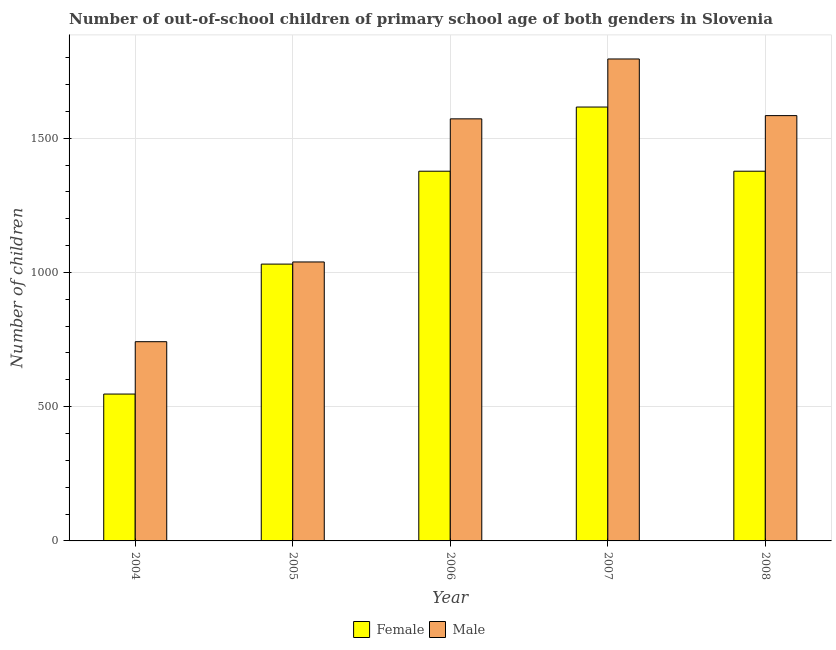How many different coloured bars are there?
Your answer should be compact. 2. How many groups of bars are there?
Keep it short and to the point. 5. Are the number of bars per tick equal to the number of legend labels?
Provide a succinct answer. Yes. Are the number of bars on each tick of the X-axis equal?
Give a very brief answer. Yes. How many bars are there on the 3rd tick from the left?
Your answer should be very brief. 2. How many bars are there on the 5th tick from the right?
Provide a short and direct response. 2. In how many cases, is the number of bars for a given year not equal to the number of legend labels?
Offer a terse response. 0. What is the number of male out-of-school students in 2004?
Give a very brief answer. 742. Across all years, what is the maximum number of male out-of-school students?
Keep it short and to the point. 1795. Across all years, what is the minimum number of female out-of-school students?
Make the answer very short. 547. In which year was the number of female out-of-school students maximum?
Make the answer very short. 2007. What is the total number of female out-of-school students in the graph?
Your response must be concise. 5948. What is the difference between the number of male out-of-school students in 2004 and that in 2007?
Give a very brief answer. -1053. What is the difference between the number of male out-of-school students in 2005 and the number of female out-of-school students in 2006?
Offer a terse response. -533. What is the average number of female out-of-school students per year?
Your answer should be compact. 1189.6. In the year 2007, what is the difference between the number of male out-of-school students and number of female out-of-school students?
Provide a succinct answer. 0. What is the ratio of the number of female out-of-school students in 2004 to that in 2007?
Make the answer very short. 0.34. Is the difference between the number of female out-of-school students in 2004 and 2007 greater than the difference between the number of male out-of-school students in 2004 and 2007?
Provide a succinct answer. No. What is the difference between the highest and the second highest number of male out-of-school students?
Your answer should be compact. 211. What is the difference between the highest and the lowest number of male out-of-school students?
Provide a succinct answer. 1053. In how many years, is the number of male out-of-school students greater than the average number of male out-of-school students taken over all years?
Give a very brief answer. 3. What does the 1st bar from the right in 2004 represents?
Provide a succinct answer. Male. How many bars are there?
Your answer should be compact. 10. How many years are there in the graph?
Offer a very short reply. 5. What is the difference between two consecutive major ticks on the Y-axis?
Keep it short and to the point. 500. Does the graph contain grids?
Your response must be concise. Yes. Where does the legend appear in the graph?
Your answer should be compact. Bottom center. How are the legend labels stacked?
Provide a succinct answer. Horizontal. What is the title of the graph?
Offer a very short reply. Number of out-of-school children of primary school age of both genders in Slovenia. Does "Malaria" appear as one of the legend labels in the graph?
Keep it short and to the point. No. What is the label or title of the X-axis?
Your response must be concise. Year. What is the label or title of the Y-axis?
Your answer should be compact. Number of children. What is the Number of children of Female in 2004?
Your answer should be very brief. 547. What is the Number of children of Male in 2004?
Keep it short and to the point. 742. What is the Number of children in Female in 2005?
Your answer should be very brief. 1031. What is the Number of children of Male in 2005?
Keep it short and to the point. 1039. What is the Number of children in Female in 2006?
Your response must be concise. 1377. What is the Number of children of Male in 2006?
Ensure brevity in your answer.  1572. What is the Number of children of Female in 2007?
Offer a very short reply. 1616. What is the Number of children of Male in 2007?
Offer a terse response. 1795. What is the Number of children in Female in 2008?
Your response must be concise. 1377. What is the Number of children of Male in 2008?
Offer a terse response. 1584. Across all years, what is the maximum Number of children in Female?
Offer a very short reply. 1616. Across all years, what is the maximum Number of children in Male?
Give a very brief answer. 1795. Across all years, what is the minimum Number of children of Female?
Make the answer very short. 547. Across all years, what is the minimum Number of children in Male?
Your answer should be very brief. 742. What is the total Number of children in Female in the graph?
Give a very brief answer. 5948. What is the total Number of children in Male in the graph?
Provide a succinct answer. 6732. What is the difference between the Number of children in Female in 2004 and that in 2005?
Offer a terse response. -484. What is the difference between the Number of children in Male in 2004 and that in 2005?
Provide a succinct answer. -297. What is the difference between the Number of children of Female in 2004 and that in 2006?
Keep it short and to the point. -830. What is the difference between the Number of children of Male in 2004 and that in 2006?
Give a very brief answer. -830. What is the difference between the Number of children in Female in 2004 and that in 2007?
Make the answer very short. -1069. What is the difference between the Number of children in Male in 2004 and that in 2007?
Give a very brief answer. -1053. What is the difference between the Number of children of Female in 2004 and that in 2008?
Make the answer very short. -830. What is the difference between the Number of children of Male in 2004 and that in 2008?
Ensure brevity in your answer.  -842. What is the difference between the Number of children of Female in 2005 and that in 2006?
Offer a terse response. -346. What is the difference between the Number of children of Male in 2005 and that in 2006?
Keep it short and to the point. -533. What is the difference between the Number of children of Female in 2005 and that in 2007?
Make the answer very short. -585. What is the difference between the Number of children in Male in 2005 and that in 2007?
Your answer should be very brief. -756. What is the difference between the Number of children of Female in 2005 and that in 2008?
Offer a very short reply. -346. What is the difference between the Number of children of Male in 2005 and that in 2008?
Offer a very short reply. -545. What is the difference between the Number of children in Female in 2006 and that in 2007?
Ensure brevity in your answer.  -239. What is the difference between the Number of children of Male in 2006 and that in 2007?
Make the answer very short. -223. What is the difference between the Number of children of Female in 2006 and that in 2008?
Make the answer very short. 0. What is the difference between the Number of children in Female in 2007 and that in 2008?
Your response must be concise. 239. What is the difference between the Number of children of Male in 2007 and that in 2008?
Ensure brevity in your answer.  211. What is the difference between the Number of children of Female in 2004 and the Number of children of Male in 2005?
Give a very brief answer. -492. What is the difference between the Number of children of Female in 2004 and the Number of children of Male in 2006?
Your response must be concise. -1025. What is the difference between the Number of children in Female in 2004 and the Number of children in Male in 2007?
Your answer should be compact. -1248. What is the difference between the Number of children of Female in 2004 and the Number of children of Male in 2008?
Give a very brief answer. -1037. What is the difference between the Number of children in Female in 2005 and the Number of children in Male in 2006?
Provide a succinct answer. -541. What is the difference between the Number of children of Female in 2005 and the Number of children of Male in 2007?
Provide a succinct answer. -764. What is the difference between the Number of children of Female in 2005 and the Number of children of Male in 2008?
Give a very brief answer. -553. What is the difference between the Number of children in Female in 2006 and the Number of children in Male in 2007?
Offer a terse response. -418. What is the difference between the Number of children of Female in 2006 and the Number of children of Male in 2008?
Your response must be concise. -207. What is the difference between the Number of children of Female in 2007 and the Number of children of Male in 2008?
Your answer should be compact. 32. What is the average Number of children of Female per year?
Offer a very short reply. 1189.6. What is the average Number of children in Male per year?
Your answer should be compact. 1346.4. In the year 2004, what is the difference between the Number of children in Female and Number of children in Male?
Make the answer very short. -195. In the year 2006, what is the difference between the Number of children in Female and Number of children in Male?
Keep it short and to the point. -195. In the year 2007, what is the difference between the Number of children in Female and Number of children in Male?
Offer a very short reply. -179. In the year 2008, what is the difference between the Number of children in Female and Number of children in Male?
Give a very brief answer. -207. What is the ratio of the Number of children in Female in 2004 to that in 2005?
Ensure brevity in your answer.  0.53. What is the ratio of the Number of children of Male in 2004 to that in 2005?
Offer a very short reply. 0.71. What is the ratio of the Number of children in Female in 2004 to that in 2006?
Your answer should be compact. 0.4. What is the ratio of the Number of children in Male in 2004 to that in 2006?
Ensure brevity in your answer.  0.47. What is the ratio of the Number of children of Female in 2004 to that in 2007?
Your answer should be very brief. 0.34. What is the ratio of the Number of children in Male in 2004 to that in 2007?
Ensure brevity in your answer.  0.41. What is the ratio of the Number of children of Female in 2004 to that in 2008?
Ensure brevity in your answer.  0.4. What is the ratio of the Number of children in Male in 2004 to that in 2008?
Your answer should be compact. 0.47. What is the ratio of the Number of children in Female in 2005 to that in 2006?
Make the answer very short. 0.75. What is the ratio of the Number of children of Male in 2005 to that in 2006?
Offer a very short reply. 0.66. What is the ratio of the Number of children of Female in 2005 to that in 2007?
Keep it short and to the point. 0.64. What is the ratio of the Number of children of Male in 2005 to that in 2007?
Your answer should be compact. 0.58. What is the ratio of the Number of children in Female in 2005 to that in 2008?
Provide a short and direct response. 0.75. What is the ratio of the Number of children in Male in 2005 to that in 2008?
Give a very brief answer. 0.66. What is the ratio of the Number of children in Female in 2006 to that in 2007?
Offer a terse response. 0.85. What is the ratio of the Number of children in Male in 2006 to that in 2007?
Give a very brief answer. 0.88. What is the ratio of the Number of children in Female in 2007 to that in 2008?
Provide a succinct answer. 1.17. What is the ratio of the Number of children in Male in 2007 to that in 2008?
Offer a very short reply. 1.13. What is the difference between the highest and the second highest Number of children in Female?
Your answer should be very brief. 239. What is the difference between the highest and the second highest Number of children in Male?
Offer a very short reply. 211. What is the difference between the highest and the lowest Number of children in Female?
Offer a terse response. 1069. What is the difference between the highest and the lowest Number of children in Male?
Your answer should be compact. 1053. 